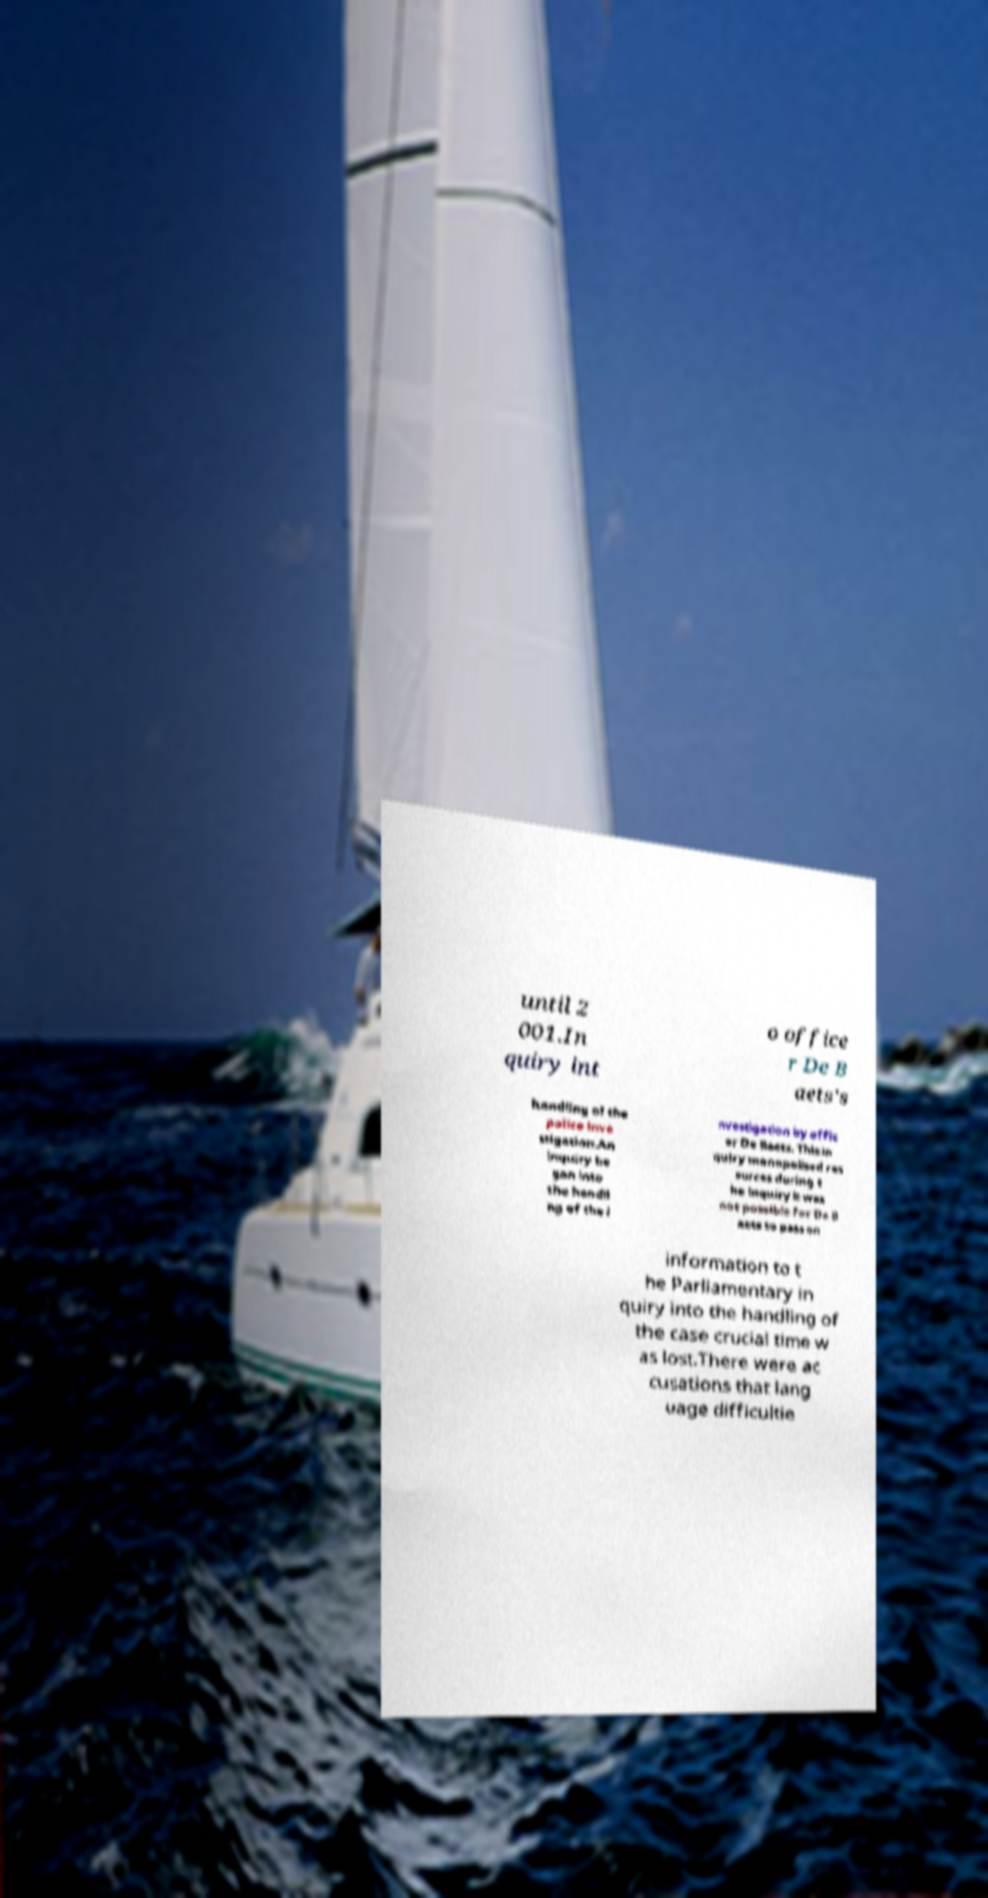I need the written content from this picture converted into text. Can you do that? until 2 001.In quiry int o office r De B aets's handling of the police inve stigation.An inquiry be gan into the handli ng of the i nvestigation by offic er De Baets. This in quiry monopolised res ources during t he inquiry it was not possible for De B aets to pass on information to t he Parliamentary in quiry into the handling of the case crucial time w as lost.There were ac cusations that lang uage difficultie 